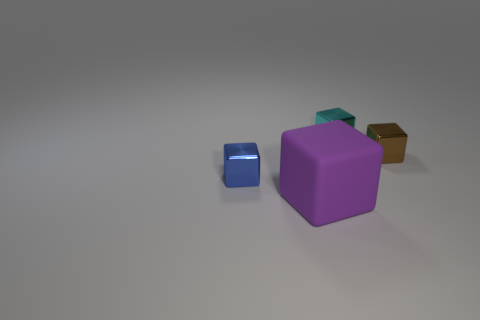What can you infer about the context or setting of the image? The image appears to be a minimalistic representation, possibly for a 3D modeling or graphic design project, given the plain background and the spotlight-type illumination on the blocks. 